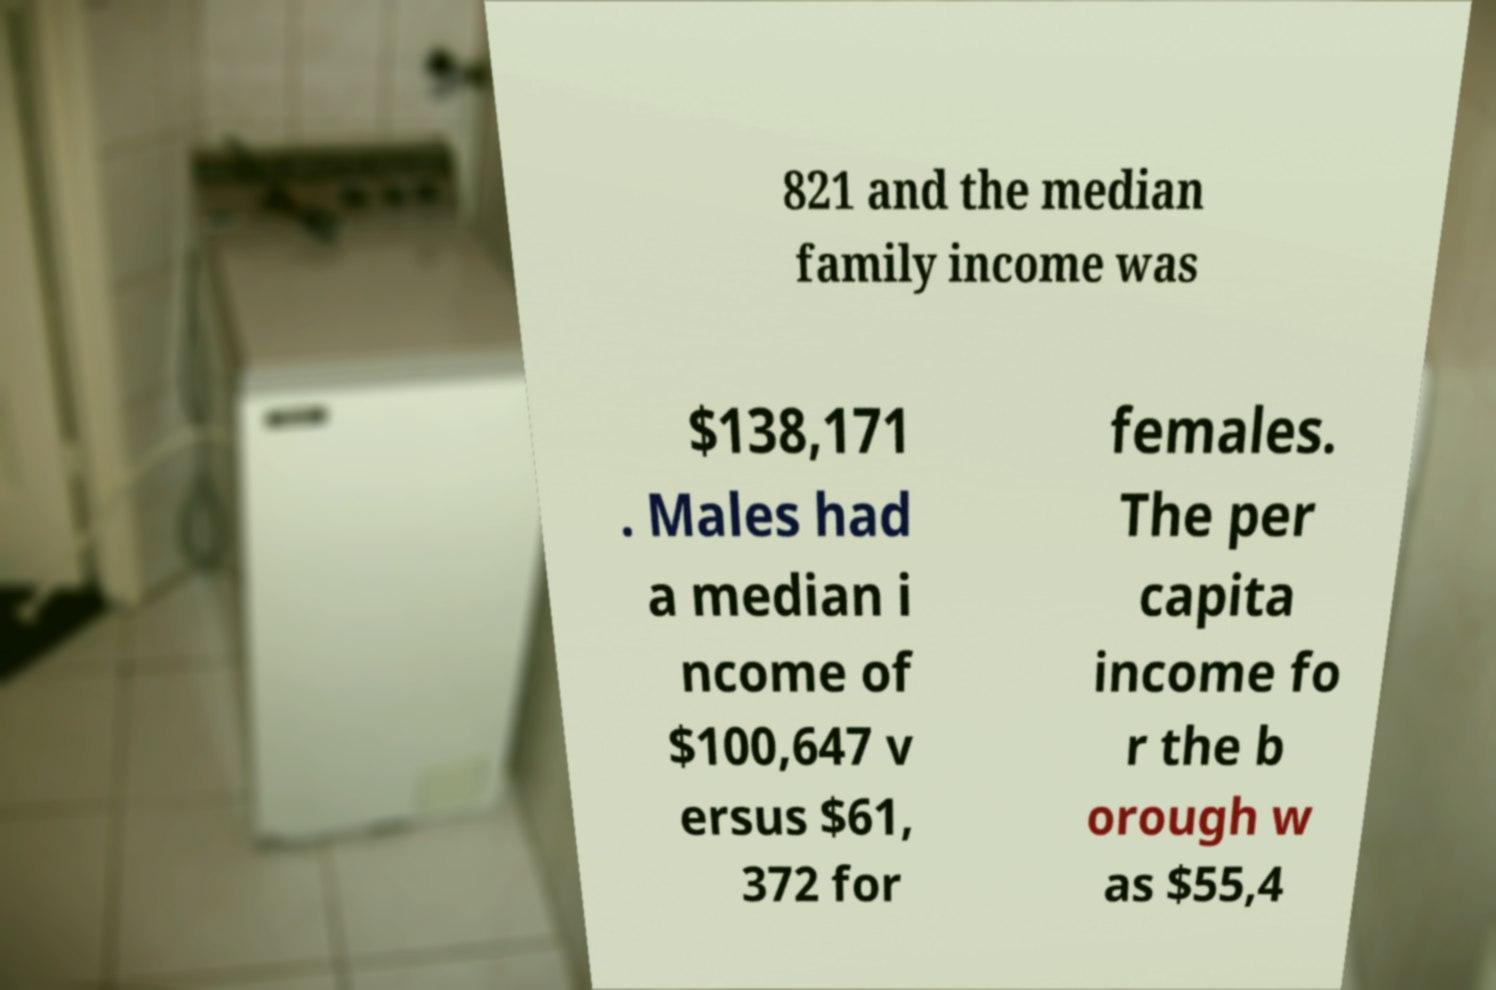Could you extract and type out the text from this image? 821 and the median family income was $138,171 . Males had a median i ncome of $100,647 v ersus $61, 372 for females. The per capita income fo r the b orough w as $55,4 